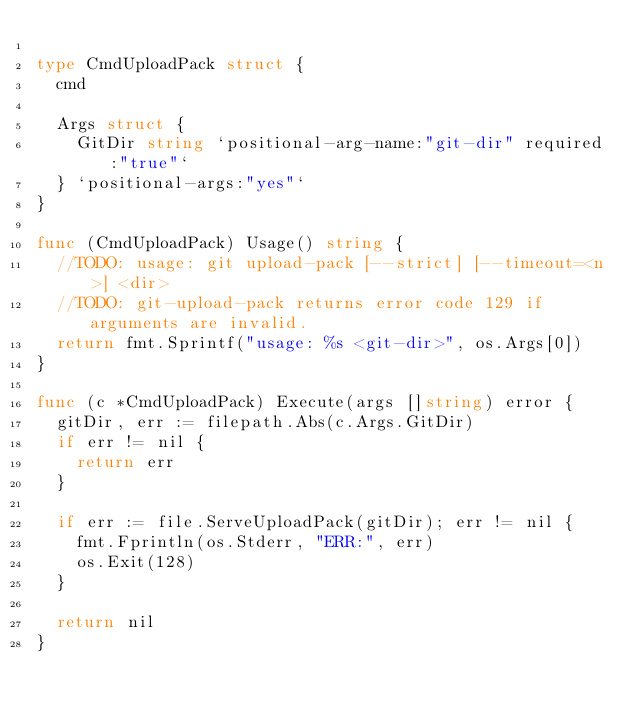<code> <loc_0><loc_0><loc_500><loc_500><_Go_>
type CmdUploadPack struct {
	cmd

	Args struct {
		GitDir string `positional-arg-name:"git-dir" required:"true"`
	} `positional-args:"yes"`
}

func (CmdUploadPack) Usage() string {
	//TODO: usage: git upload-pack [--strict] [--timeout=<n>] <dir>
	//TODO: git-upload-pack returns error code 129 if arguments are invalid.
	return fmt.Sprintf("usage: %s <git-dir>", os.Args[0])
}

func (c *CmdUploadPack) Execute(args []string) error {
	gitDir, err := filepath.Abs(c.Args.GitDir)
	if err != nil {
		return err
	}

	if err := file.ServeUploadPack(gitDir); err != nil {
		fmt.Fprintln(os.Stderr, "ERR:", err)
		os.Exit(128)
	}

	return nil
}
</code> 